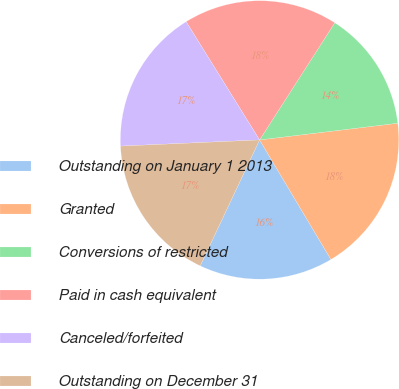<chart> <loc_0><loc_0><loc_500><loc_500><pie_chart><fcel>Outstanding on January 1 2013<fcel>Granted<fcel>Conversions of restricted<fcel>Paid in cash equivalent<fcel>Canceled/forfeited<fcel>Outstanding on December 31<nl><fcel>15.57%<fcel>18.35%<fcel>14.0%<fcel>17.93%<fcel>16.86%<fcel>17.28%<nl></chart> 